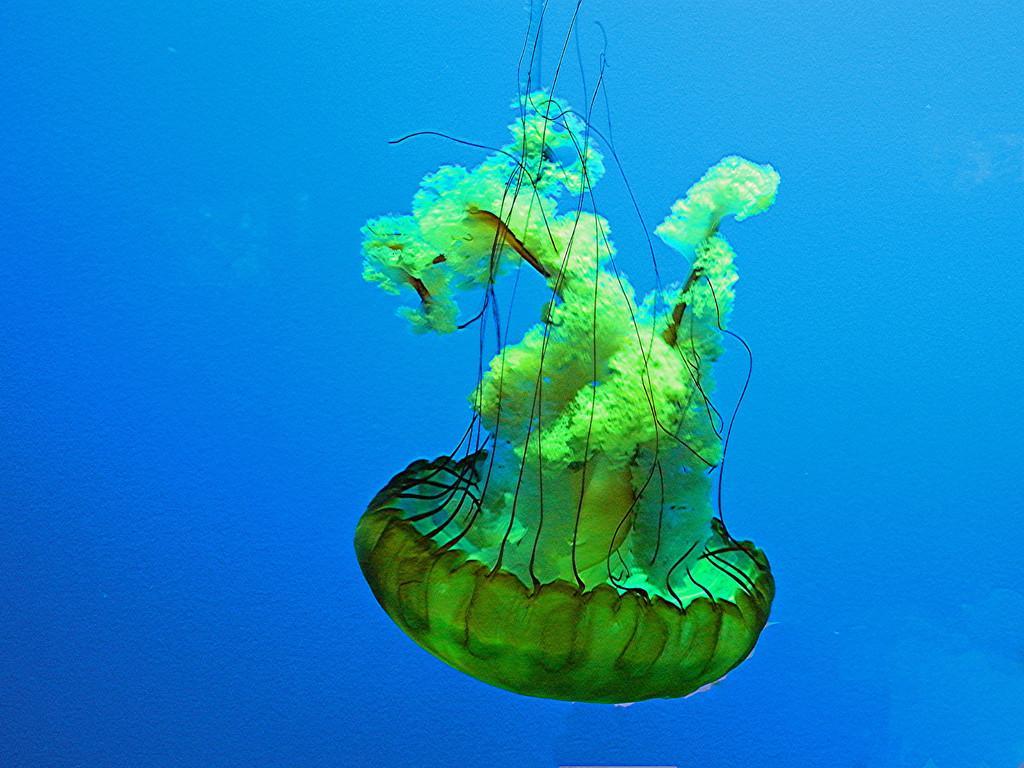Can you describe this image briefly? In this image we can see a jellyfish in the water. 